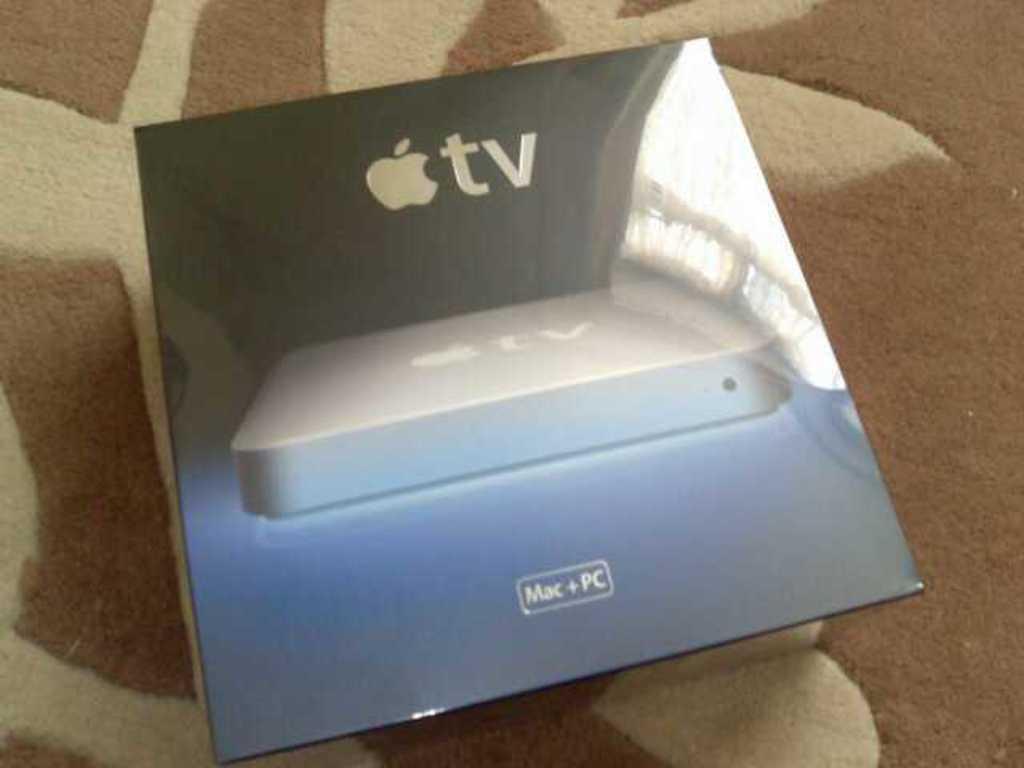What is next to the apple symbol?
Keep it short and to the point. Tv. What two types of computers are mentioned below?
Your answer should be compact. Mac & pc. 